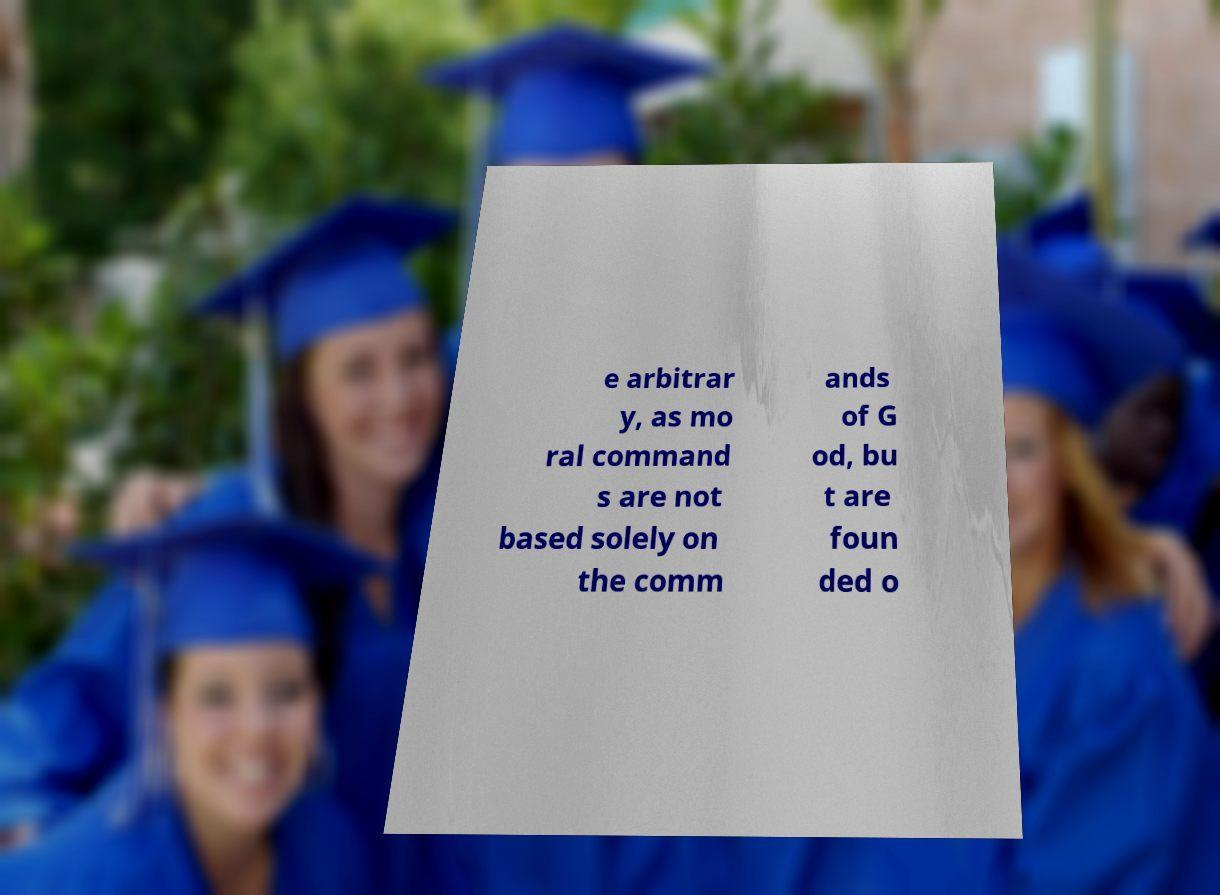Can you read and provide the text displayed in the image?This photo seems to have some interesting text. Can you extract and type it out for me? e arbitrar y, as mo ral command s are not based solely on the comm ands of G od, bu t are foun ded o 